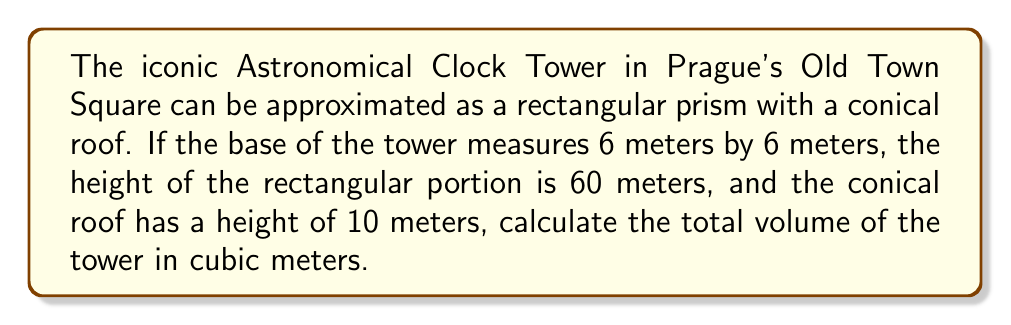What is the answer to this math problem? Let's break this problem down into steps:

1. Calculate the volume of the rectangular prism (main body of the tower):
   $$V_{prism} = l \times w \times h$$
   $$V_{prism} = 6 \text{ m} \times 6 \text{ m} \times 60 \text{ m} = 2160 \text{ m}^3$$

2. Calculate the volume of the conical roof:
   The volume of a cone is given by the formula:
   $$V_{cone} = \frac{1}{3} \pi r^2 h$$
   
   Where $r$ is the radius of the base and $h$ is the height of the cone.
   The radius of the base is half the width of the tower:
   $$r = 6 \text{ m} \div 2 = 3 \text{ m}$$

   Now we can calculate the volume of the cone:
   $$V_{cone} = \frac{1}{3} \pi (3 \text{ m})^2 (10 \text{ m}) = 30\pi \text{ m}^3$$

3. Sum the volumes of the prism and cone:
   $$V_{total} = V_{prism} + V_{cone}$$
   $$V_{total} = 2160 \text{ m}^3 + 30\pi \text{ m}^3$$
   $$V_{total} = 2160 + 94.25 = 2254.25 \text{ m}^3$$

Therefore, the total volume of the Astronomical Clock Tower is approximately 2254.25 cubic meters.
Answer: $2254.25 \text{ m}^3$ 